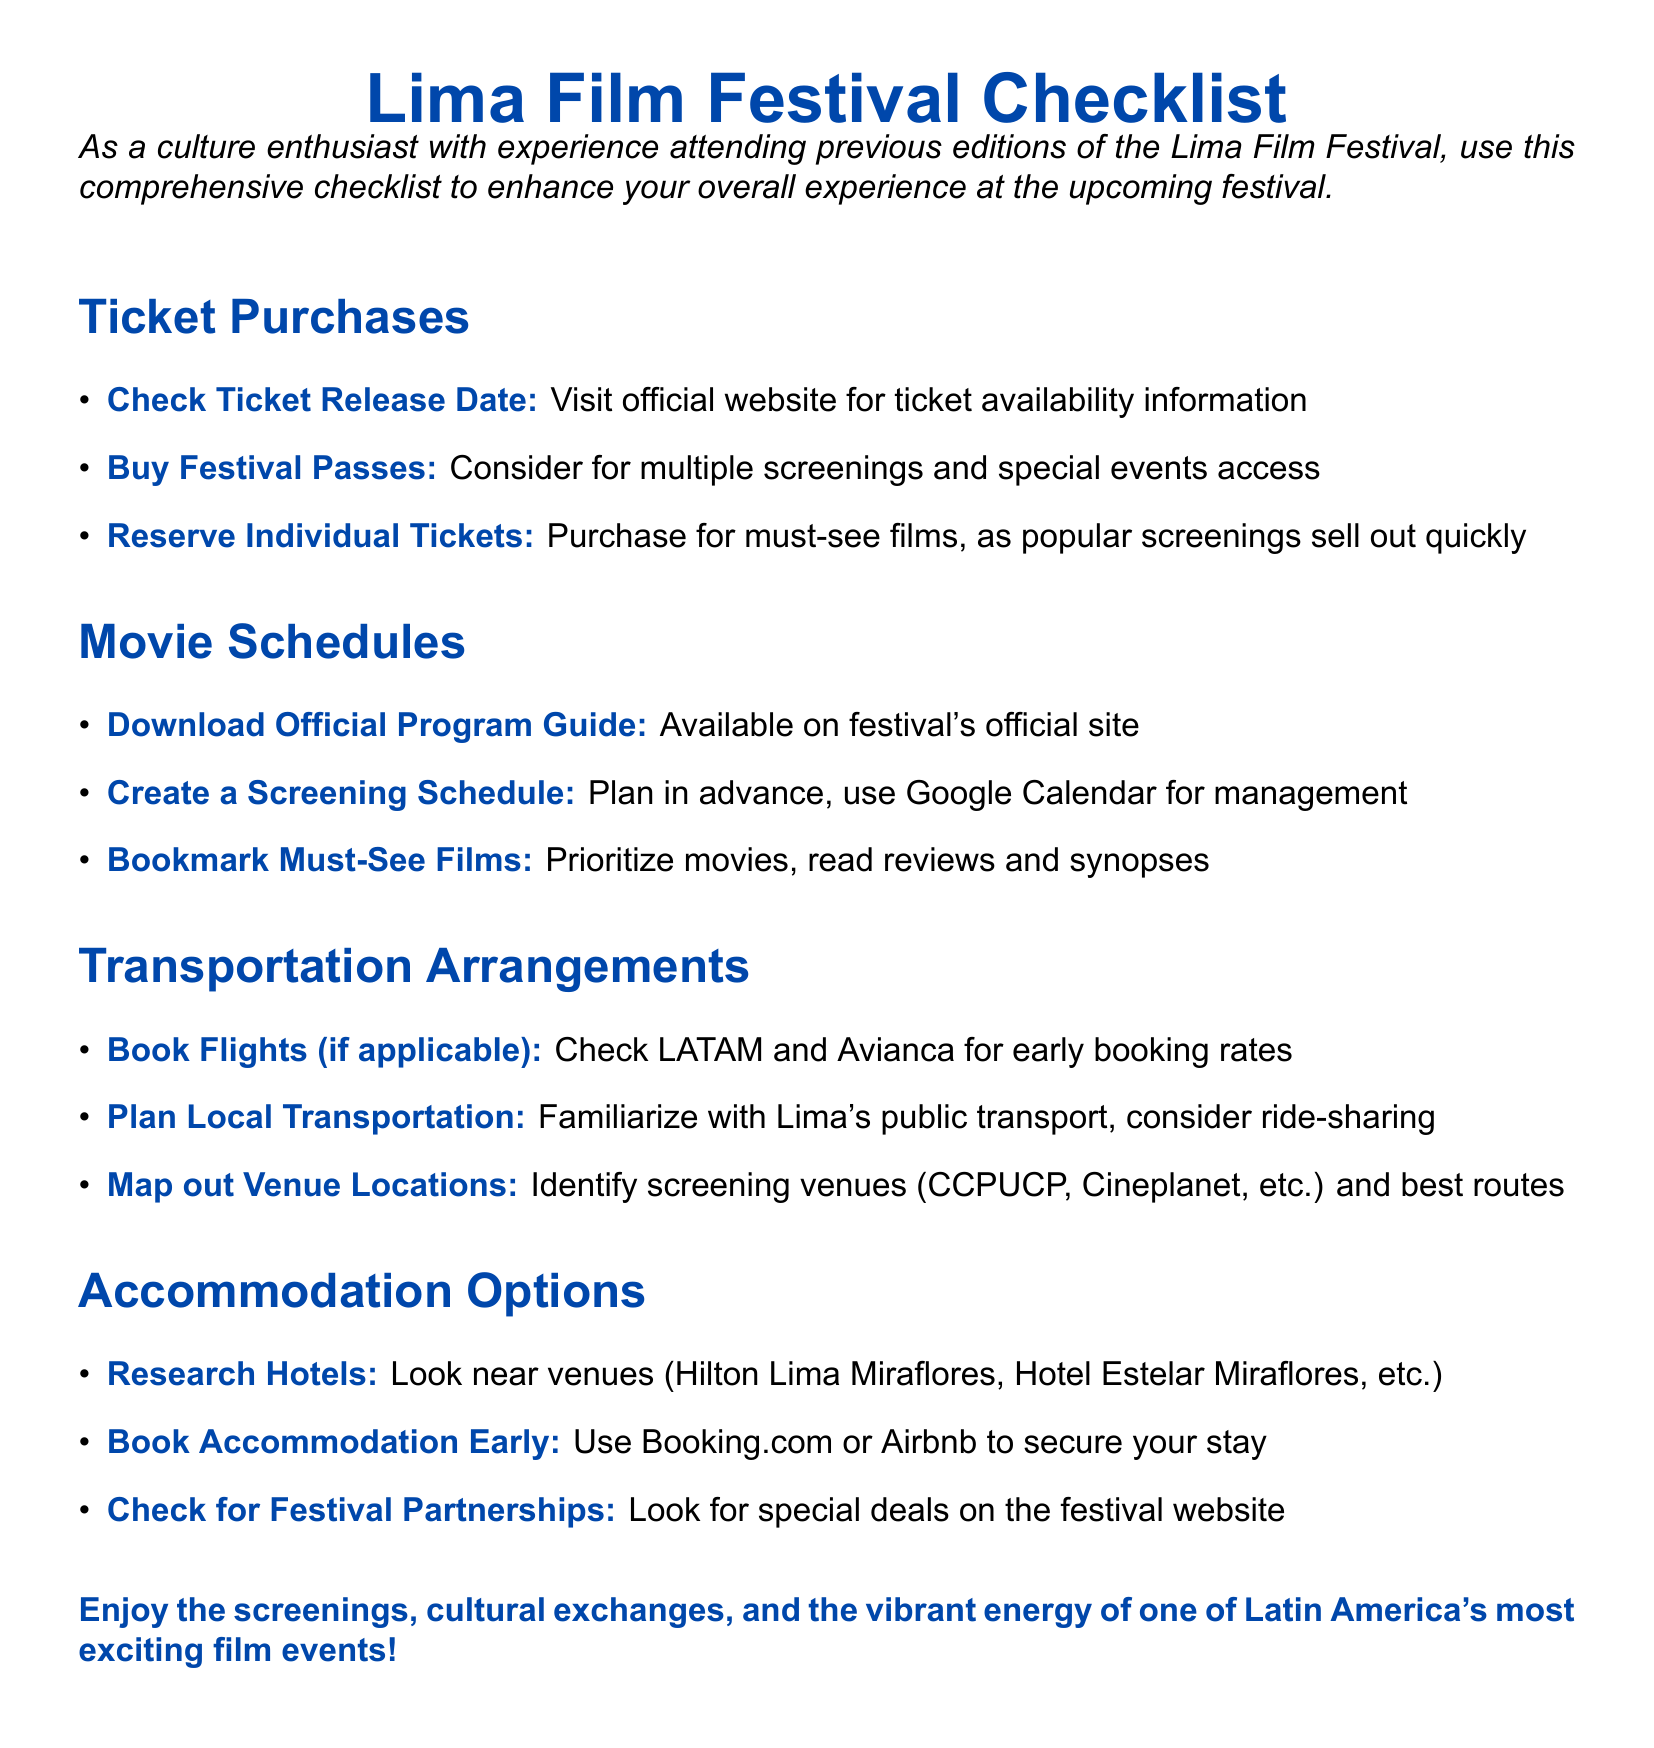What should you do before buying tickets? The document states to check the ticket release date on the official website for availability information before purchasing.
Answer: Check Ticket Release Date Which hotels are recommended near the festival venues? The checklist provides examples of hotels such as Hilton Lima Miraflores and Hotel Estelar Miraflores.
Answer: Hilton Lima Miraflores, Hotel Estelar Miraflores What should you prioritize when creating a screening schedule? The document suggests bookmarking must-see films and reading reviews and synopses to prioritize your selections.
Answer: Must-See Films What platforms are suggested for booking flights? The checklist mentions LATAM and Avianca as options for checking early booking rates for flights.
Answer: LATAM and Avianca What is the purpose of reserving individual tickets? The reasoning in the document indicates that individual tickets should be reserved for must-see films since popular screenings sell out quickly.
Answer: Must-See Films What tool is recommended for managing your screening schedule? The checklist suggests using Google Calendar for management purposes.
Answer: Google Calendar 